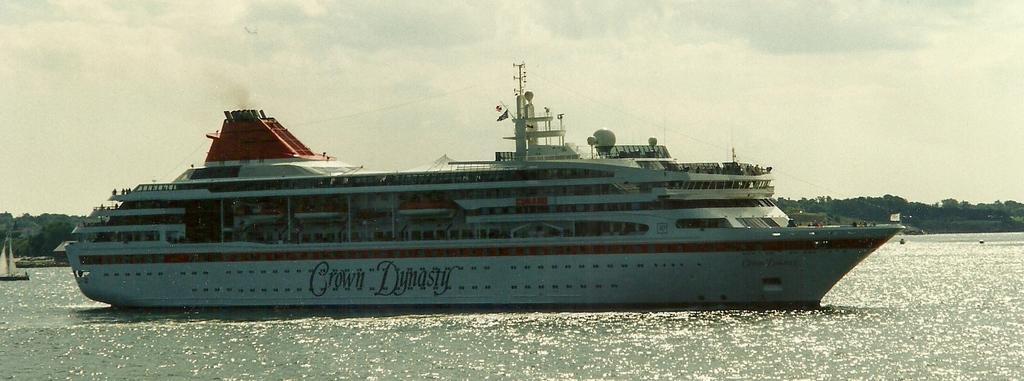Please provide a concise description of this image. In this picture we can see a ship on water and in the background we can see trees,sky. 